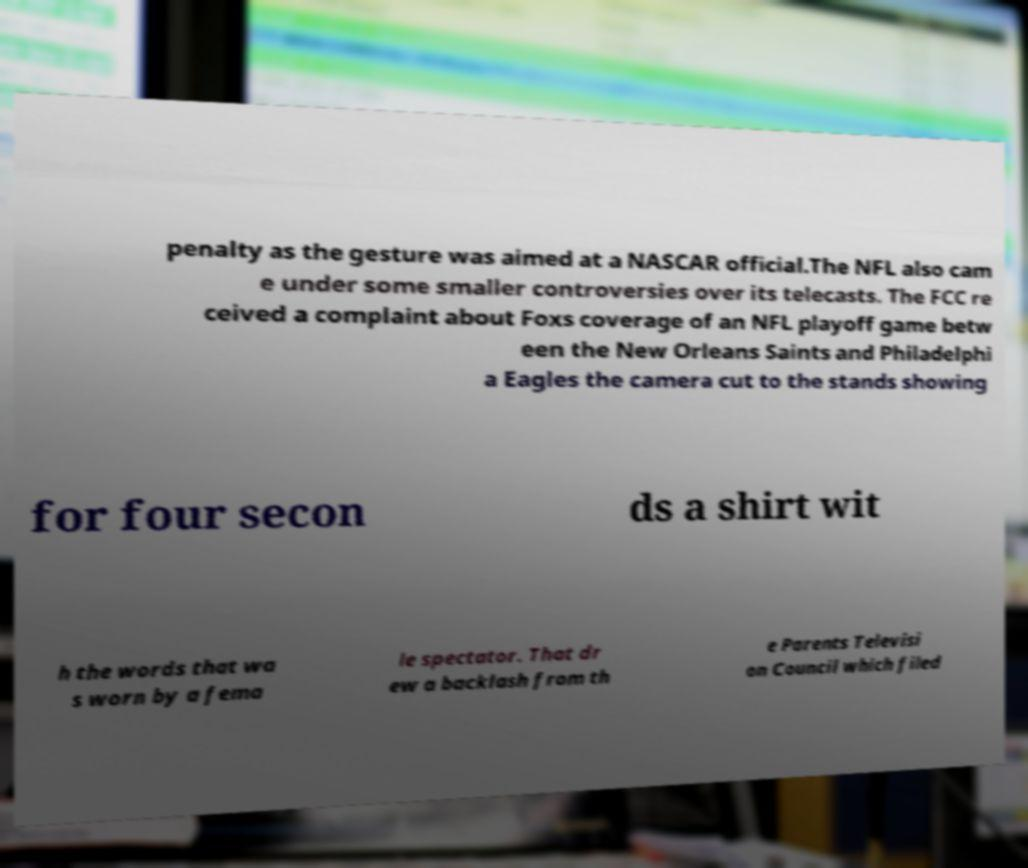Please read and relay the text visible in this image. What does it say? penalty as the gesture was aimed at a NASCAR official.The NFL also cam e under some smaller controversies over its telecasts. The FCC re ceived a complaint about Foxs coverage of an NFL playoff game betw een the New Orleans Saints and Philadelphi a Eagles the camera cut to the stands showing for four secon ds a shirt wit h the words that wa s worn by a fema le spectator. That dr ew a backlash from th e Parents Televisi on Council which filed 